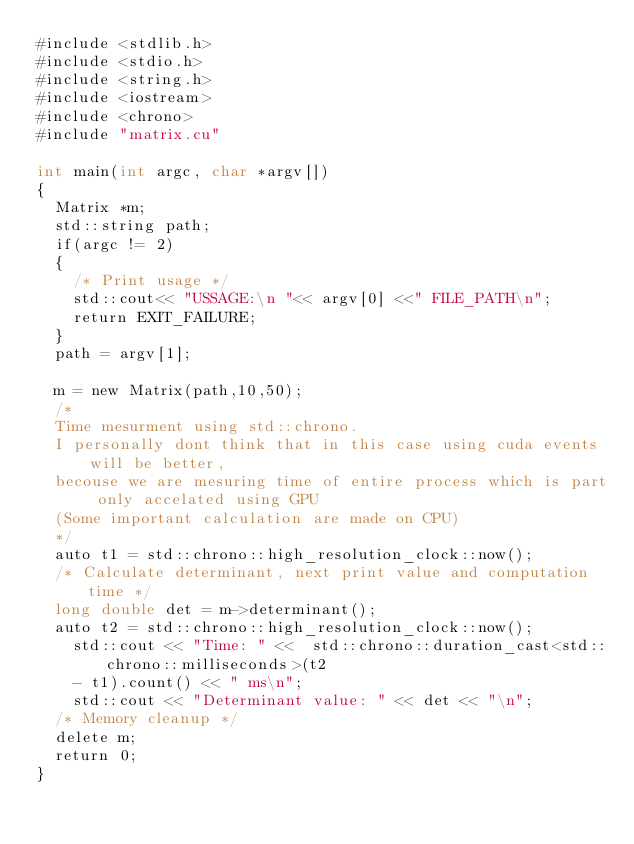<code> <loc_0><loc_0><loc_500><loc_500><_Cuda_>#include <stdlib.h>
#include <stdio.h>
#include <string.h>
#include <iostream>
#include <chrono>
#include "matrix.cu"

int main(int argc, char *argv[])
{
	Matrix *m;
	std::string path;
	if(argc != 2)
	{
		/* Print usage */
		std::cout<< "USSAGE:\n "<< argv[0] <<" FILE_PATH\n";
		return EXIT_FAILURE;
	}
	path = argv[1];

	m = new Matrix(path,10,50);
	/*
	Time mesurment using std::chrono.
	I personally dont think that in this case using cuda events will be better,
	becouse we are mesuring time of entire process which is part only accelated using GPU 
	(Some important calculation are made on CPU)
	*/
	auto t1 = std::chrono::high_resolution_clock::now();
	/* Calculate determinant, next print value and computation time */
	long double det = m->determinant();
	auto t2 = std::chrono::high_resolution_clock::now();
    std::cout << "Time: " <<  std::chrono::duration_cast<std::chrono::milliseconds>(t2 
		- t1).count() << " ms\n";
    std::cout << "Determinant value: " << det << "\n";
	/* Memory cleanup */
	delete m;
	return 0;
}
</code> 